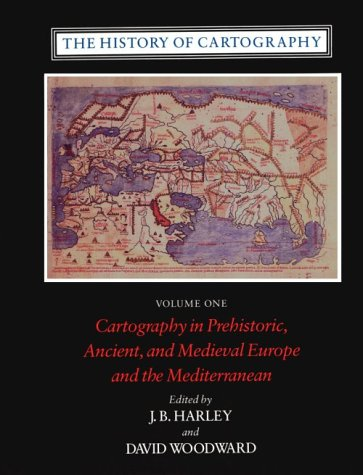What is the title of this book? The title of the book shown is 'The History of Cartography: Cartography in Prehistoric, Ancient, and Medieval Europe and the Mediterranean, Vol. 1'. It's a detailed exploration of how maps have evolved over time across different cultures and epochs. 